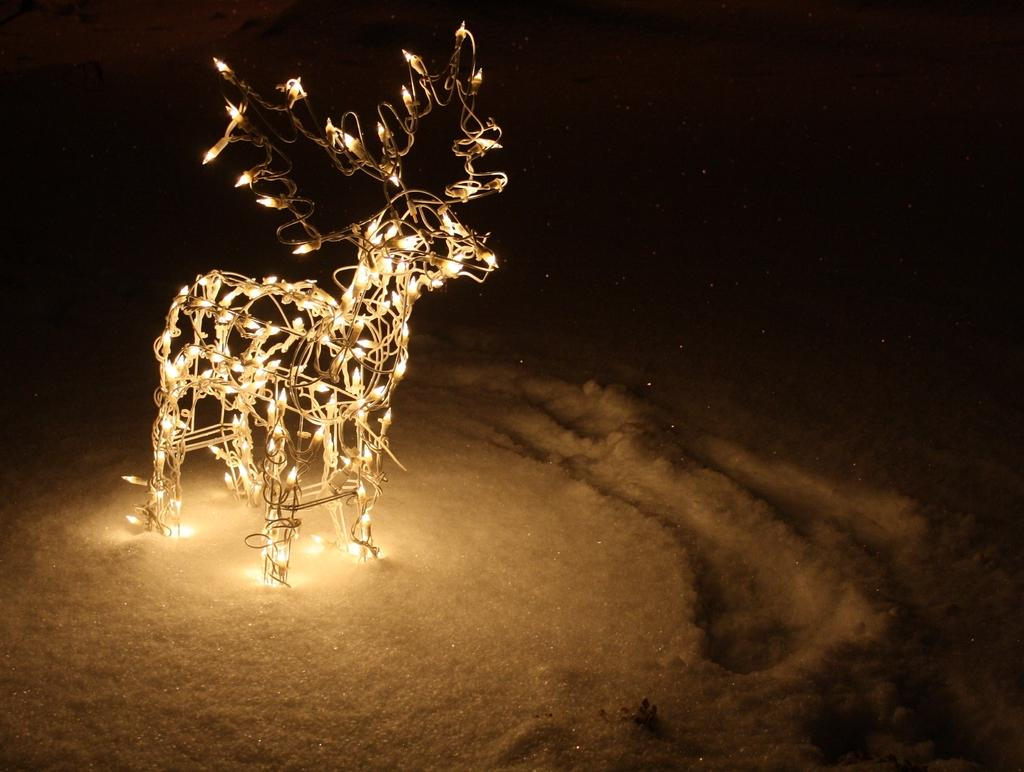What animal can be seen in the image? There is a deer in the image. Where is the deer located in the image? The deer is on a path. What is the color of the background in the image? The background of the image is dark. Can you see any ducks in the image? No, there are no ducks present in the image. How many feet does the deer have in the image? The image does not show the deer's feet, so it is not possible to determine the number of feet. 